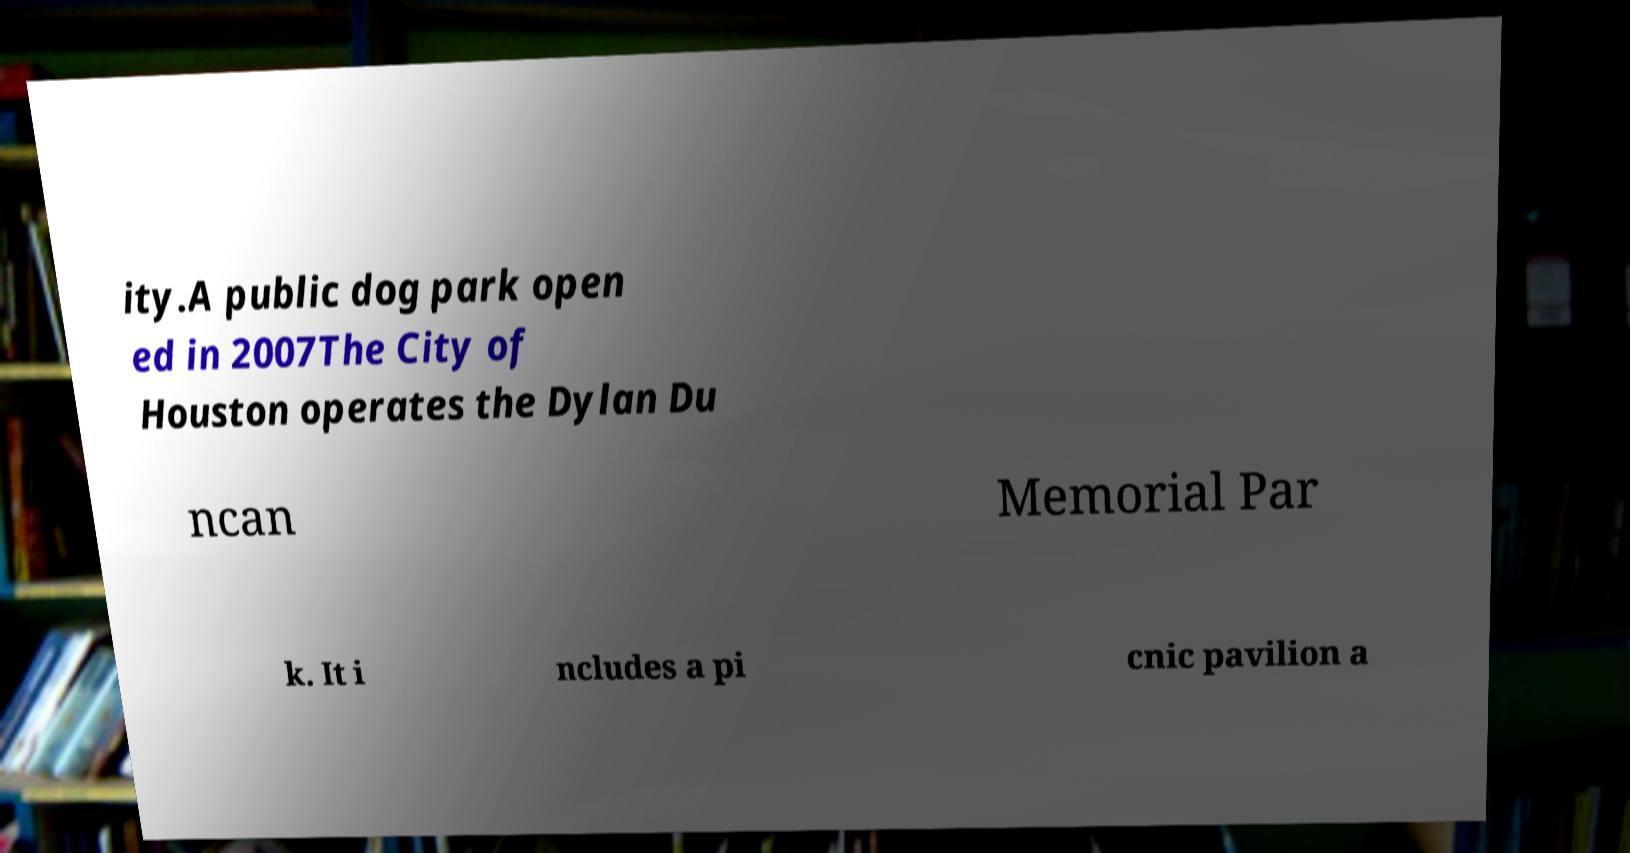Can you read and provide the text displayed in the image?This photo seems to have some interesting text. Can you extract and type it out for me? ity.A public dog park open ed in 2007The City of Houston operates the Dylan Du ncan Memorial Par k. It i ncludes a pi cnic pavilion a 